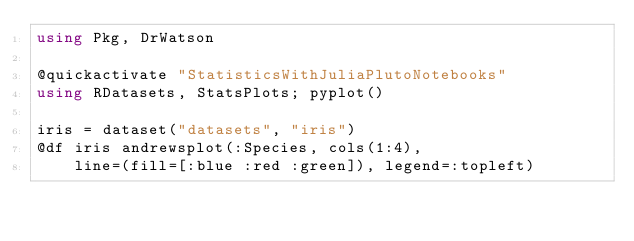<code> <loc_0><loc_0><loc_500><loc_500><_Julia_>using Pkg, DrWatson

@quickactivate "StatisticsWithJuliaPlutoNotebooks"
using RDatasets, StatsPlots; pyplot()

iris = dataset("datasets", "iris")
@df iris andrewsplot(:Species, cols(1:4), 
    line=(fill=[:blue :red :green]), legend=:topleft)
</code> 